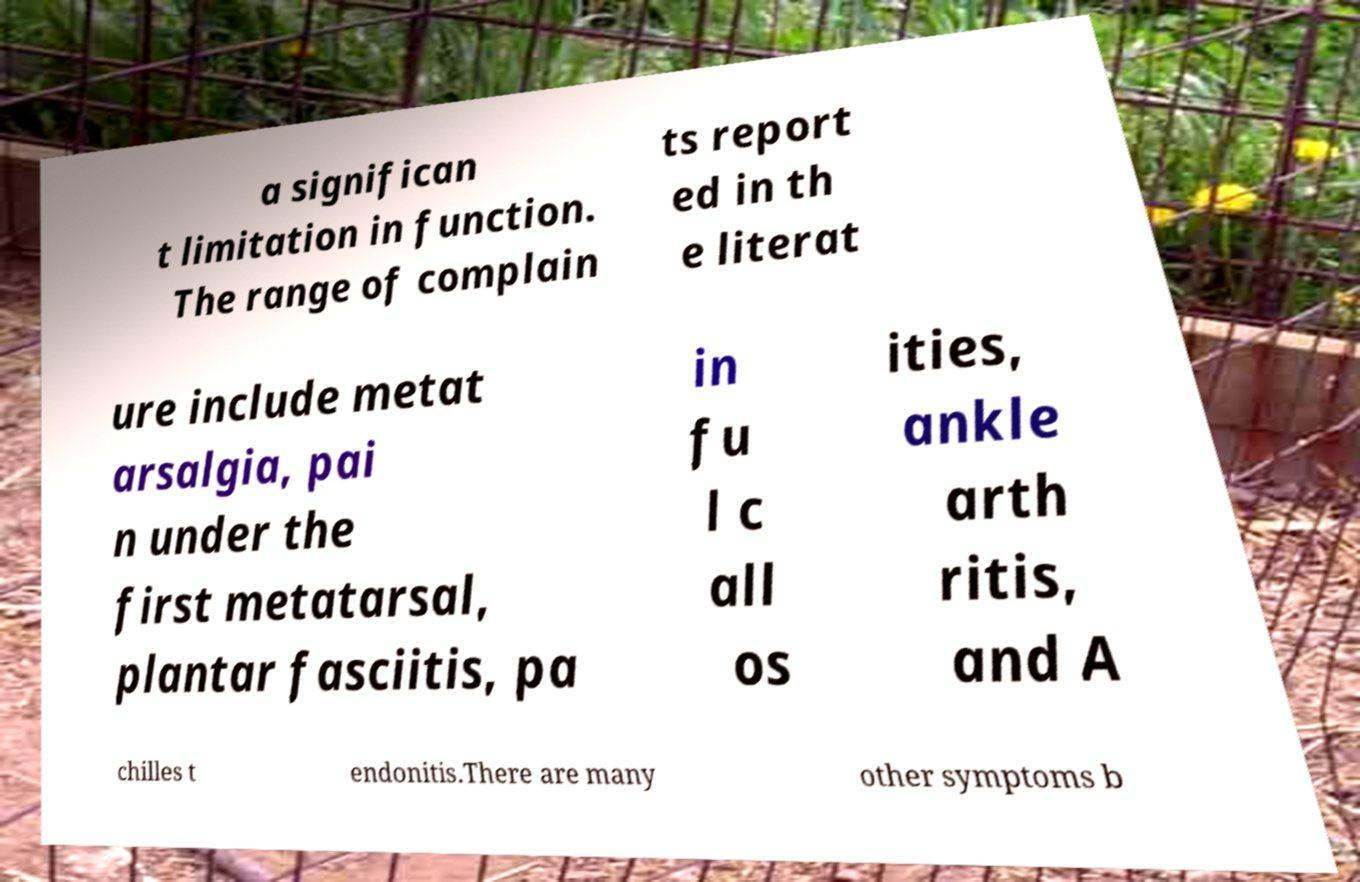Could you extract and type out the text from this image? a significan t limitation in function. The range of complain ts report ed in th e literat ure include metat arsalgia, pai n under the first metatarsal, plantar fasciitis, pa in fu l c all os ities, ankle arth ritis, and A chilles t endonitis.There are many other symptoms b 